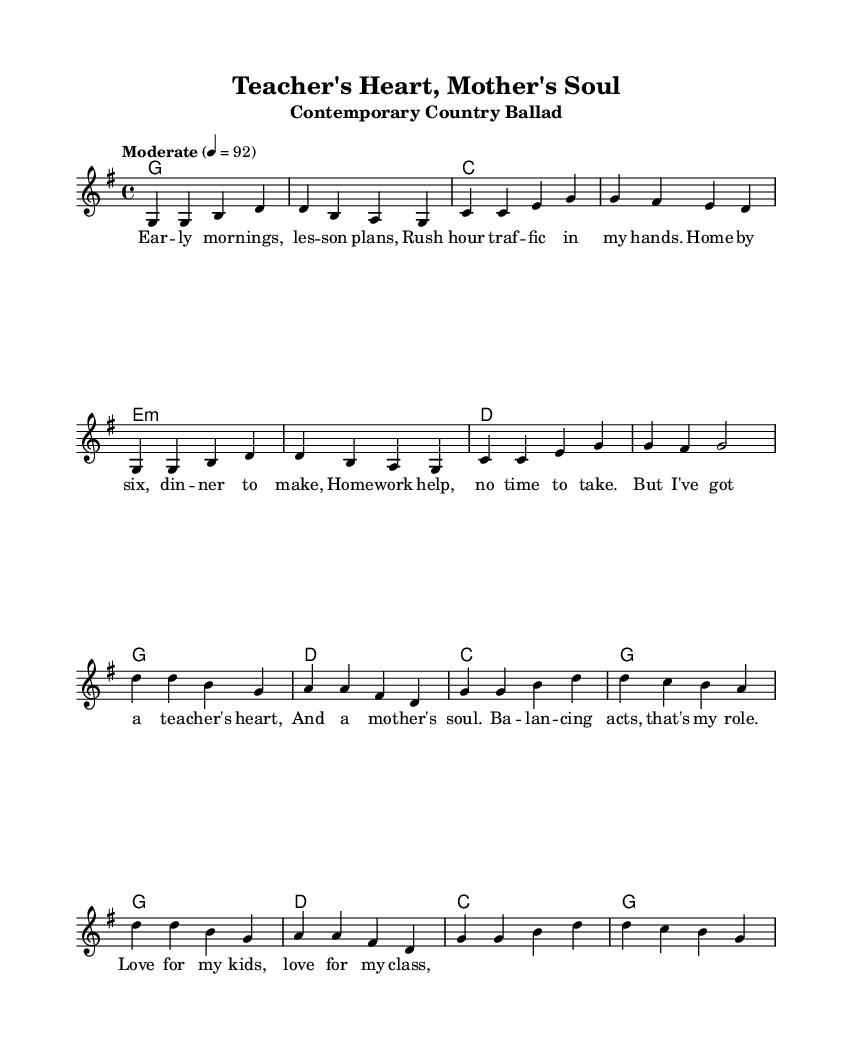What is the key signature of this music? The key signature is G major, which has one sharp (F#). This can be identified at the beginning of the staff, where sharps are indicated.
Answer: G major What is the time signature of this music? The time signature is 4/4, which indicates there are 4 beats in a measure and the quarter note gets one beat. This is indicated at the beginning of the score next to the key signature.
Answer: 4/4 What is the tempo marking for this piece? The tempo marking is "Moderate" set to 92 beats per minute, as noted at the start of the score. This tells performers the speed at which to play the music.
Answer: Moderate 92 How many measures are in the verse? The verse consists of 8 individual measures, which can be counted by looking at the grouping of notes between each double bar line.
Answer: 8 What is the emotional theme expressed in the lyrics of the chorus? The chorus conveys a sense of balance between personal and professional life, emphasizing love for both kids and the teaching profession, evident from the lyrics that discuss a teacher's heart and a mother's soul.
Answer: Balance What chords are used in the chorus? The chords in the chorus are G, D, and C, which reinforce the musical structure and accompany the melody. The chords are outlined under the melody, showing the harmonic progression.
Answer: G, D, C What kind of song structure does this piece have? The structure consists of verses and a chorus, which is typical of contemporary country music. The alternation between descriptive verses and an emotional chorus is a common framework in this genre.
Answer: Verse-Chorus 